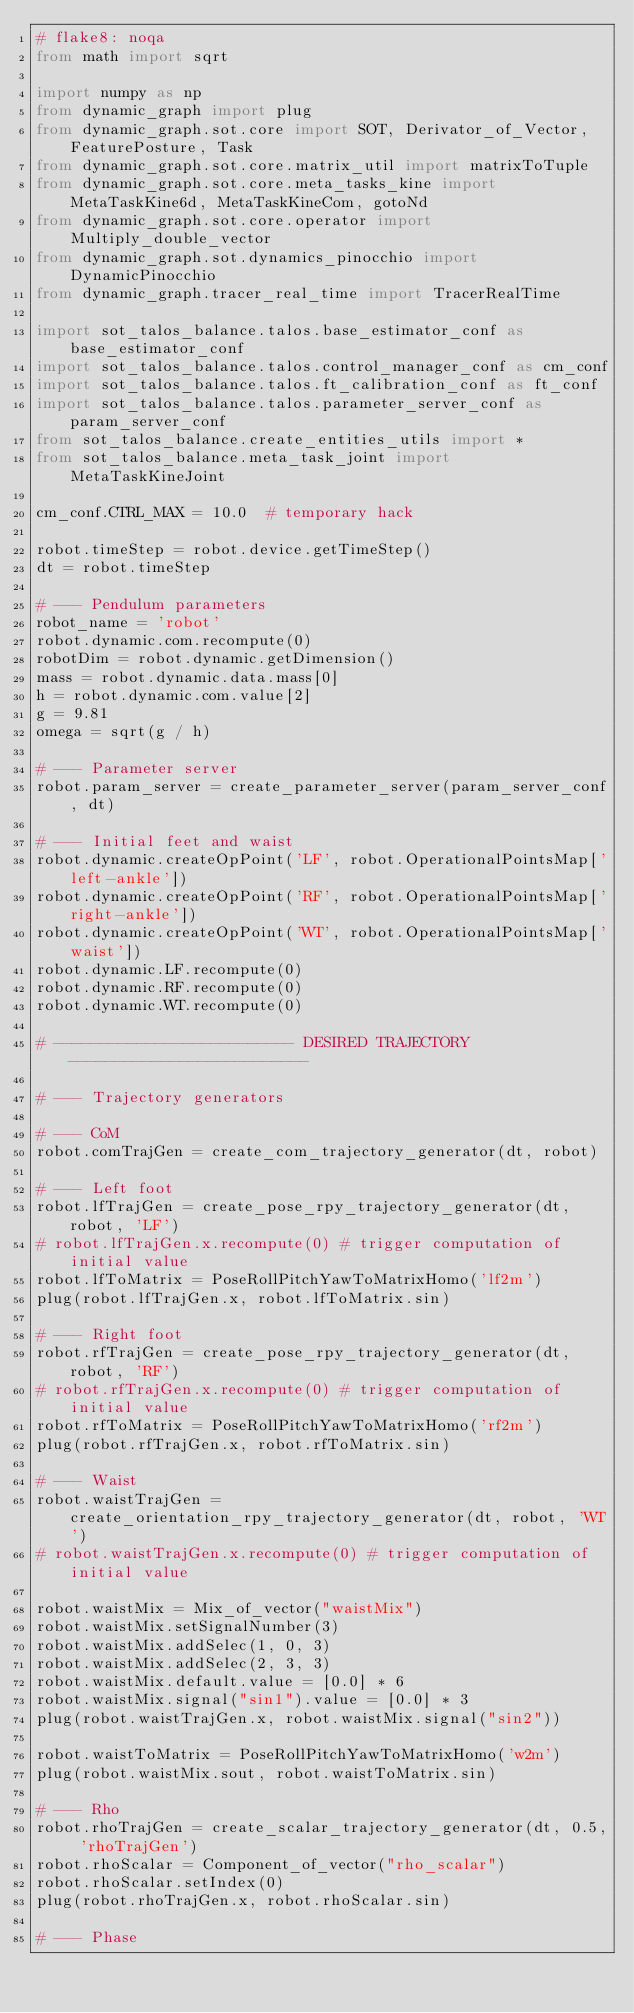Convert code to text. <code><loc_0><loc_0><loc_500><loc_500><_Python_># flake8: noqa
from math import sqrt

import numpy as np
from dynamic_graph import plug
from dynamic_graph.sot.core import SOT, Derivator_of_Vector, FeaturePosture, Task
from dynamic_graph.sot.core.matrix_util import matrixToTuple
from dynamic_graph.sot.core.meta_tasks_kine import MetaTaskKine6d, MetaTaskKineCom, gotoNd
from dynamic_graph.sot.core.operator import Multiply_double_vector
from dynamic_graph.sot.dynamics_pinocchio import DynamicPinocchio
from dynamic_graph.tracer_real_time import TracerRealTime

import sot_talos_balance.talos.base_estimator_conf as base_estimator_conf
import sot_talos_balance.talos.control_manager_conf as cm_conf
import sot_talos_balance.talos.ft_calibration_conf as ft_conf
import sot_talos_balance.talos.parameter_server_conf as param_server_conf
from sot_talos_balance.create_entities_utils import *
from sot_talos_balance.meta_task_joint import MetaTaskKineJoint

cm_conf.CTRL_MAX = 10.0  # temporary hack

robot.timeStep = robot.device.getTimeStep()
dt = robot.timeStep

# --- Pendulum parameters
robot_name = 'robot'
robot.dynamic.com.recompute(0)
robotDim = robot.dynamic.getDimension()
mass = robot.dynamic.data.mass[0]
h = robot.dynamic.com.value[2]
g = 9.81
omega = sqrt(g / h)

# --- Parameter server
robot.param_server = create_parameter_server(param_server_conf, dt)

# --- Initial feet and waist
robot.dynamic.createOpPoint('LF', robot.OperationalPointsMap['left-ankle'])
robot.dynamic.createOpPoint('RF', robot.OperationalPointsMap['right-ankle'])
robot.dynamic.createOpPoint('WT', robot.OperationalPointsMap['waist'])
robot.dynamic.LF.recompute(0)
robot.dynamic.RF.recompute(0)
robot.dynamic.WT.recompute(0)

# -------------------------- DESIRED TRAJECTORY --------------------------

# --- Trajectory generators

# --- CoM
robot.comTrajGen = create_com_trajectory_generator(dt, robot)

# --- Left foot
robot.lfTrajGen = create_pose_rpy_trajectory_generator(dt, robot, 'LF')
# robot.lfTrajGen.x.recompute(0) # trigger computation of initial value
robot.lfToMatrix = PoseRollPitchYawToMatrixHomo('lf2m')
plug(robot.lfTrajGen.x, robot.lfToMatrix.sin)

# --- Right foot
robot.rfTrajGen = create_pose_rpy_trajectory_generator(dt, robot, 'RF')
# robot.rfTrajGen.x.recompute(0) # trigger computation of initial value
robot.rfToMatrix = PoseRollPitchYawToMatrixHomo('rf2m')
plug(robot.rfTrajGen.x, robot.rfToMatrix.sin)

# --- Waist
robot.waistTrajGen = create_orientation_rpy_trajectory_generator(dt, robot, 'WT')
# robot.waistTrajGen.x.recompute(0) # trigger computation of initial value

robot.waistMix = Mix_of_vector("waistMix")
robot.waistMix.setSignalNumber(3)
robot.waistMix.addSelec(1, 0, 3)
robot.waistMix.addSelec(2, 3, 3)
robot.waistMix.default.value = [0.0] * 6
robot.waistMix.signal("sin1").value = [0.0] * 3
plug(robot.waistTrajGen.x, robot.waistMix.signal("sin2"))

robot.waistToMatrix = PoseRollPitchYawToMatrixHomo('w2m')
plug(robot.waistMix.sout, robot.waistToMatrix.sin)

# --- Rho
robot.rhoTrajGen = create_scalar_trajectory_generator(dt, 0.5, 'rhoTrajGen')
robot.rhoScalar = Component_of_vector("rho_scalar")
robot.rhoScalar.setIndex(0)
plug(robot.rhoTrajGen.x, robot.rhoScalar.sin)

# --- Phase</code> 